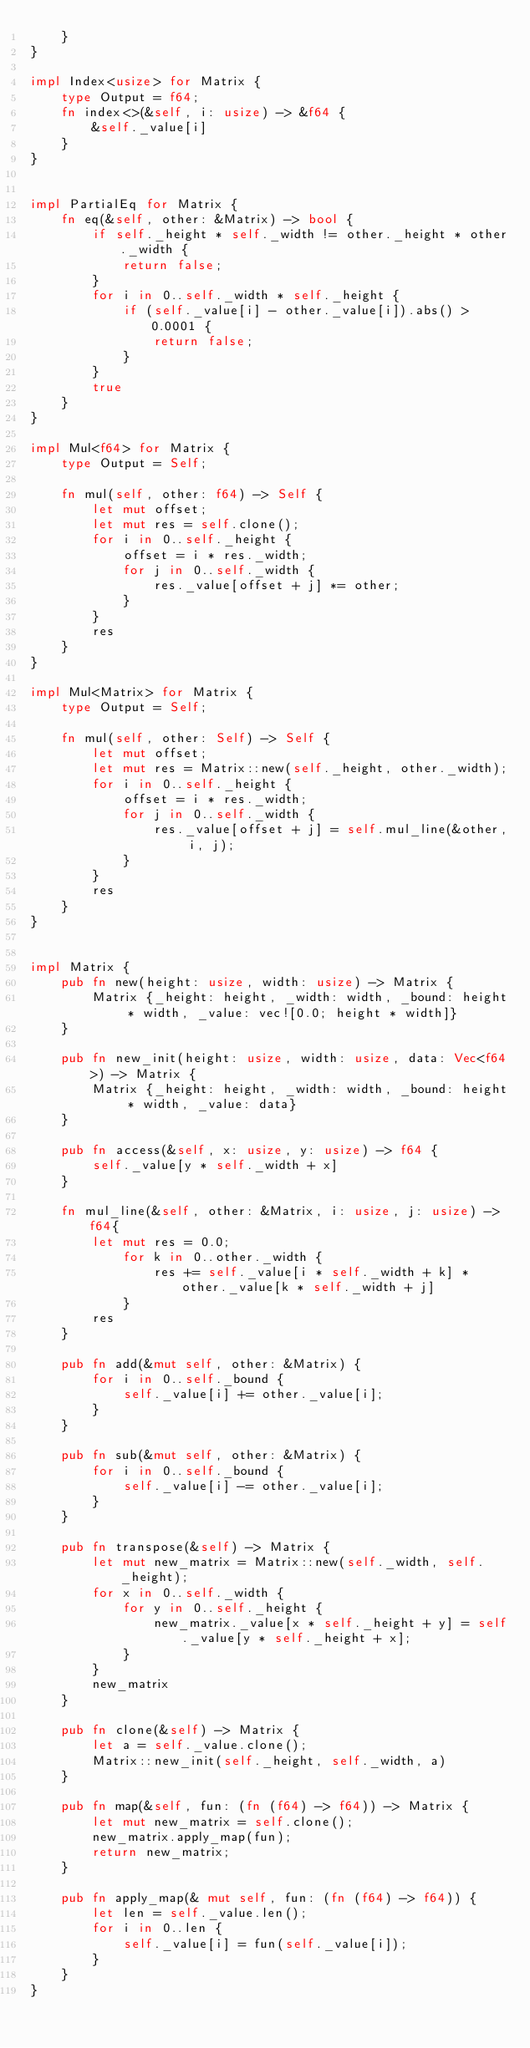Convert code to text. <code><loc_0><loc_0><loc_500><loc_500><_Rust_>    }
}

impl Index<usize> for Matrix {
    type Output = f64;
    fn index<>(&self, i: usize) -> &f64 {
        &self._value[i]
    }
}


impl PartialEq for Matrix {
    fn eq(&self, other: &Matrix) -> bool {
        if self._height * self._width != other._height * other._width {
            return false;
        }
        for i in 0..self._width * self._height {
            if (self._value[i] - other._value[i]).abs() > 0.0001 {
                return false;
            }
        }
        true
    }
}

impl Mul<f64> for Matrix {
    type Output = Self;

    fn mul(self, other: f64) -> Self {
        let mut offset;
        let mut res = self.clone();
        for i in 0..self._height {
            offset = i * res._width;
            for j in 0..self._width {
                res._value[offset + j] *= other;
            }
        }
        res
    }
}

impl Mul<Matrix> for Matrix {
    type Output = Self;

    fn mul(self, other: Self) -> Self {
        let mut offset;
        let mut res = Matrix::new(self._height, other._width);
        for i in 0..self._height {
            offset = i * res._width;
            for j in 0..self._width {
                res._value[offset + j] = self.mul_line(&other, i, j);
            }
        }
        res
    }
}


impl Matrix {
    pub fn new(height: usize, width: usize) -> Matrix {
        Matrix {_height: height, _width: width, _bound: height * width, _value: vec![0.0; height * width]}
    }

    pub fn new_init(height: usize, width: usize, data: Vec<f64>) -> Matrix {
        Matrix {_height: height, _width: width, _bound: height * width, _value: data}
    }

    pub fn access(&self, x: usize, y: usize) -> f64 {
        self._value[y * self._width + x]
    }

    fn mul_line(&self, other: &Matrix, i: usize, j: usize) -> f64{
        let mut res = 0.0;
            for k in 0..other._width {
                res += self._value[i * self._width + k] * other._value[k * self._width + j]
            }
        res
    }

    pub fn add(&mut self, other: &Matrix) {
        for i in 0..self._bound {
            self._value[i] += other._value[i];
        }
    }

    pub fn sub(&mut self, other: &Matrix) {
        for i in 0..self._bound {
            self._value[i] -= other._value[i];
        }
    }

    pub fn transpose(&self) -> Matrix {
        let mut new_matrix = Matrix::new(self._width, self._height);
        for x in 0..self._width {
            for y in 0..self._height {
                new_matrix._value[x * self._height + y] = self._value[y * self._height + x];
            }
        }
        new_matrix
    }

    pub fn clone(&self) -> Matrix {
        let a = self._value.clone();
        Matrix::new_init(self._height, self._width, a)
    }

    pub fn map(&self, fun: (fn (f64) -> f64)) -> Matrix {
        let mut new_matrix = self.clone();
        new_matrix.apply_map(fun);
        return new_matrix;
    }

    pub fn apply_map(& mut self, fun: (fn (f64) -> f64)) {
        let len = self._value.len();
        for i in 0..len {
            self._value[i] = fun(self._value[i]);
        }
    }
}</code> 